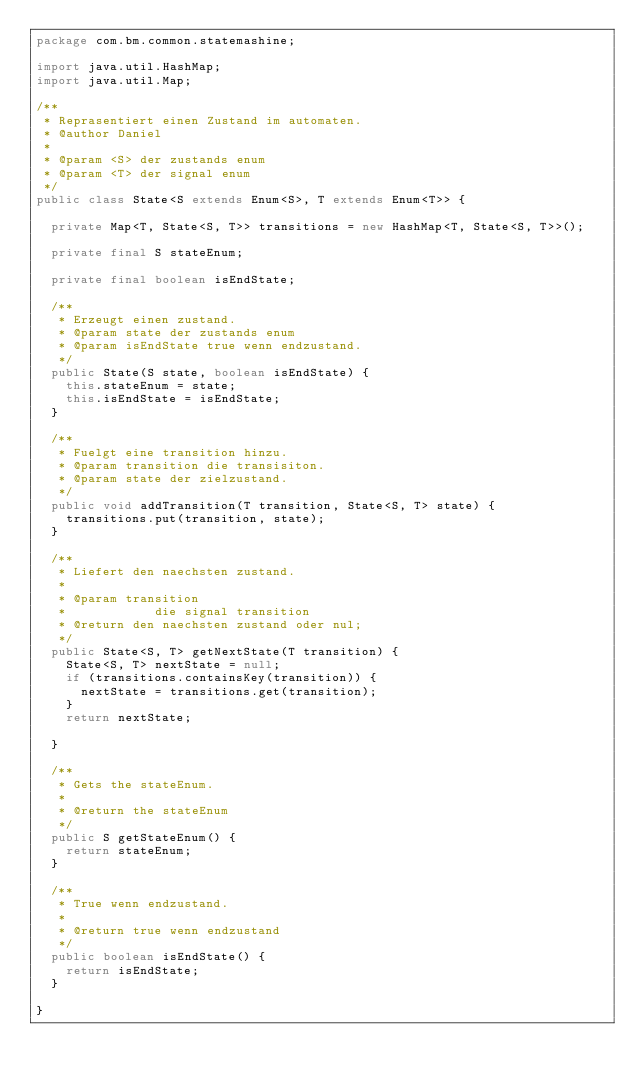<code> <loc_0><loc_0><loc_500><loc_500><_Java_>package com.bm.common.statemashine;

import java.util.HashMap;
import java.util.Map;

/**
 * Reprasentiert einen Zustand im automaten.
 * @author Daniel
 *
 * @param <S> der zustands enum
 * @param <T> der signal enum
 */
public class State<S extends Enum<S>, T extends Enum<T>> {

	private Map<T, State<S, T>> transitions = new HashMap<T, State<S, T>>();

	private final S stateEnum;

	private final boolean isEndState;

	/**
	 * Erzeugt einen zustand.
	 * @param state der zustands enum
	 * @param isEndState true wenn endzustand.
	 */
	public State(S state, boolean isEndState) {
		this.stateEnum = state;
		this.isEndState = isEndState;
	}

	/**
	 * Fuelgt eine transition hinzu.
	 * @param transition die transisiton.
	 * @param state der zielzustand.
	 */
	public void addTransition(T transition, State<S, T> state) {
		transitions.put(transition, state);
	}

	/**
	 * Liefert den naechsten zustand.
	 * 
	 * @param transition
	 *            die signal transition
	 * @return den naechsten zustand oder nul;
	 */
	public State<S, T> getNextState(T transition) {
		State<S, T> nextState = null;
		if (transitions.containsKey(transition)) {
			nextState = transitions.get(transition);
		}
		return nextState;

	}

	/**
	 * Gets the stateEnum.
	 * 
	 * @return the stateEnum
	 */
	public S getStateEnum() {
		return stateEnum;
	}

	/**
	 * True wenn endzustand.
	 * 
	 * @return true wenn endzustand
	 */
	public boolean isEndState() {
		return isEndState;
	}

}
</code> 